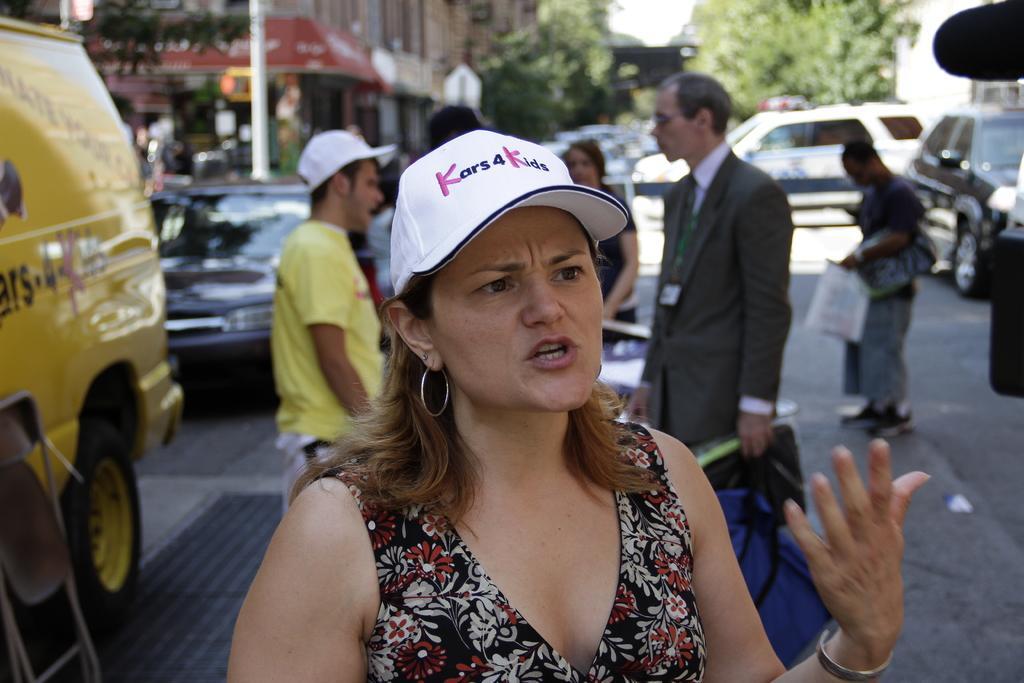In one or two sentences, can you explain what this image depicts? This image is clicked on the road. There are a few people standing on the road. In the foreground there is a woman standing. She is wearing a cap. There is text on the cap. There are cars parked on the road. In the background there are trees, buildings and a pole. 